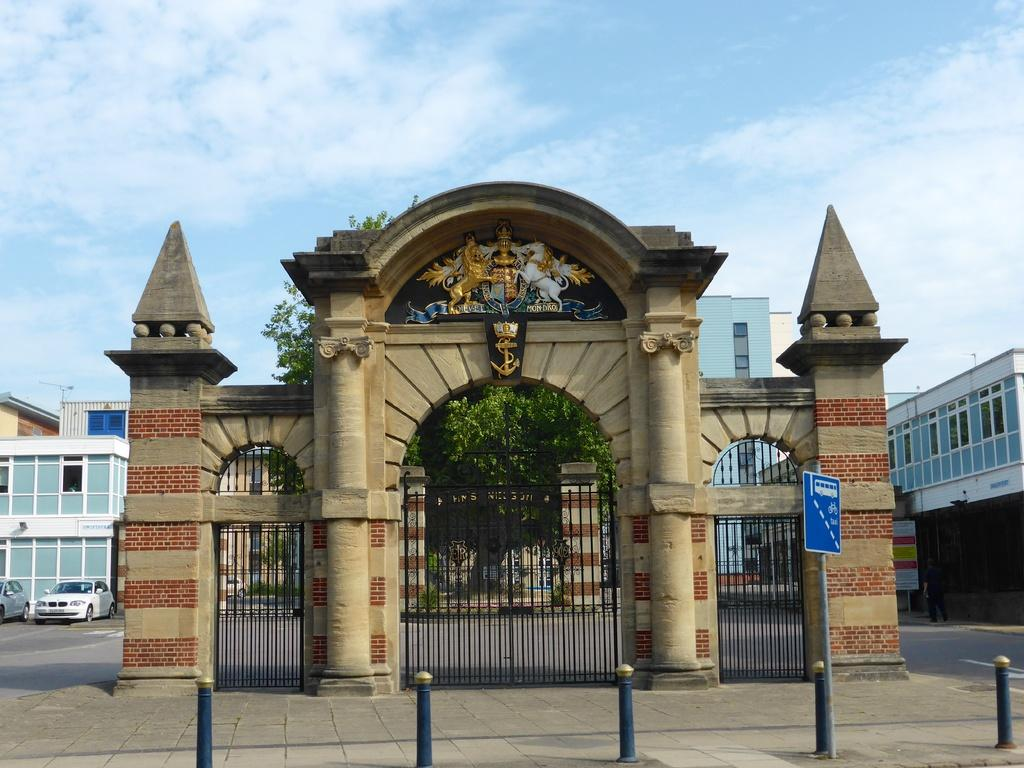What architectural features can be seen in the image? There are arches, boards, and poles in the image. What type of structures are present in the image? There are grills in the image. What can be seen in the background of the image? There are buildings, vehicles, trees, and a person in the background of the image. The sky is also visible in the background. What is the condition of the sky in the image? The sky is cloudy in the image. Where is the office located in the image? There is no office present in the image. What type of watch is the person wearing in the image? There is no person wearing a watch in the image. Can you see any animals in the image? There is no mention of animals or a zoo in the image. 